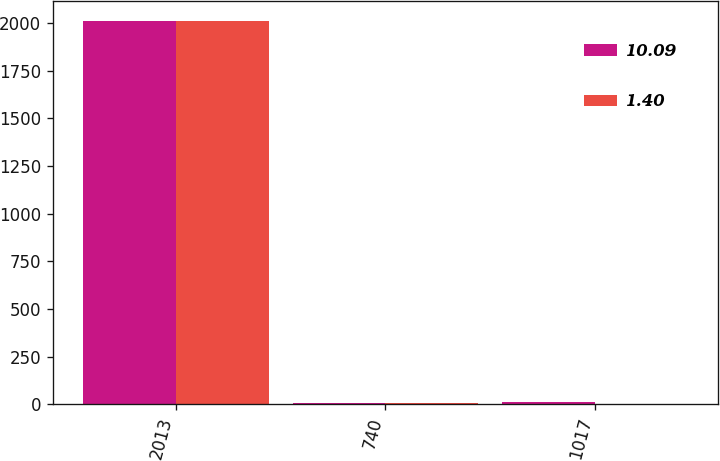<chart> <loc_0><loc_0><loc_500><loc_500><stacked_bar_chart><ecel><fcel>2013<fcel>740<fcel>1017<nl><fcel>10.09<fcel>2012<fcel>7.42<fcel>10.09<nl><fcel>1.4<fcel>2011<fcel>7.52<fcel>1.4<nl></chart> 